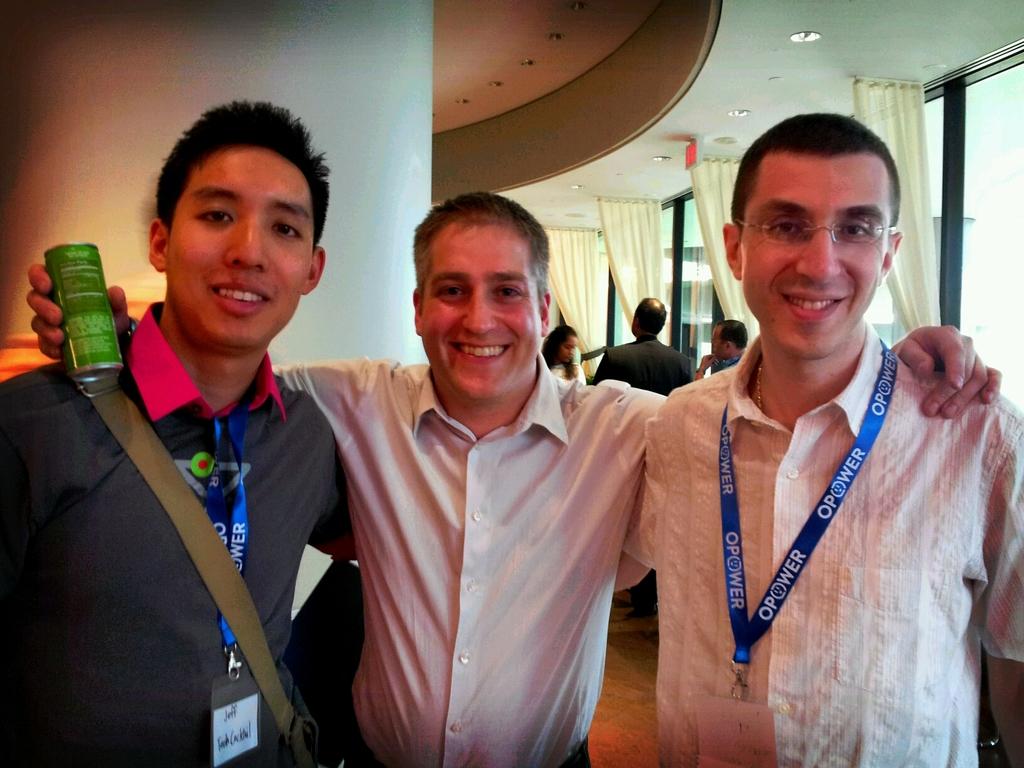What is the name of the man in the black shirt?
Your answer should be compact. Jeff. 